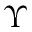Convert formula to latex. <formula><loc_0><loc_0><loc_500><loc_500>\Upsilon</formula> 